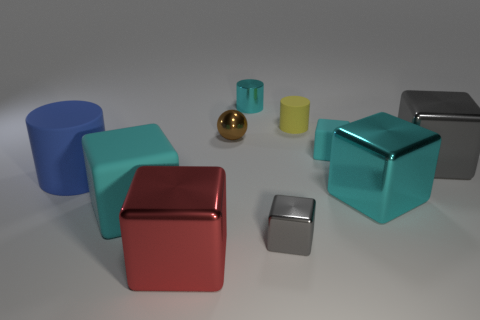Subtract all cyan cubes. How many were subtracted if there are1cyan cubes left? 2 Subtract all gray spheres. How many cyan cubes are left? 3 Subtract all small cyan matte cubes. How many cubes are left? 5 Subtract all red cubes. How many cubes are left? 5 Subtract all yellow blocks. Subtract all brown cylinders. How many blocks are left? 6 Subtract all blocks. How many objects are left? 4 Add 3 blue matte cylinders. How many blue matte cylinders are left? 4 Add 6 cyan shiny cylinders. How many cyan shiny cylinders exist? 7 Subtract 0 brown cylinders. How many objects are left? 10 Subtract all large yellow blocks. Subtract all cyan cylinders. How many objects are left? 9 